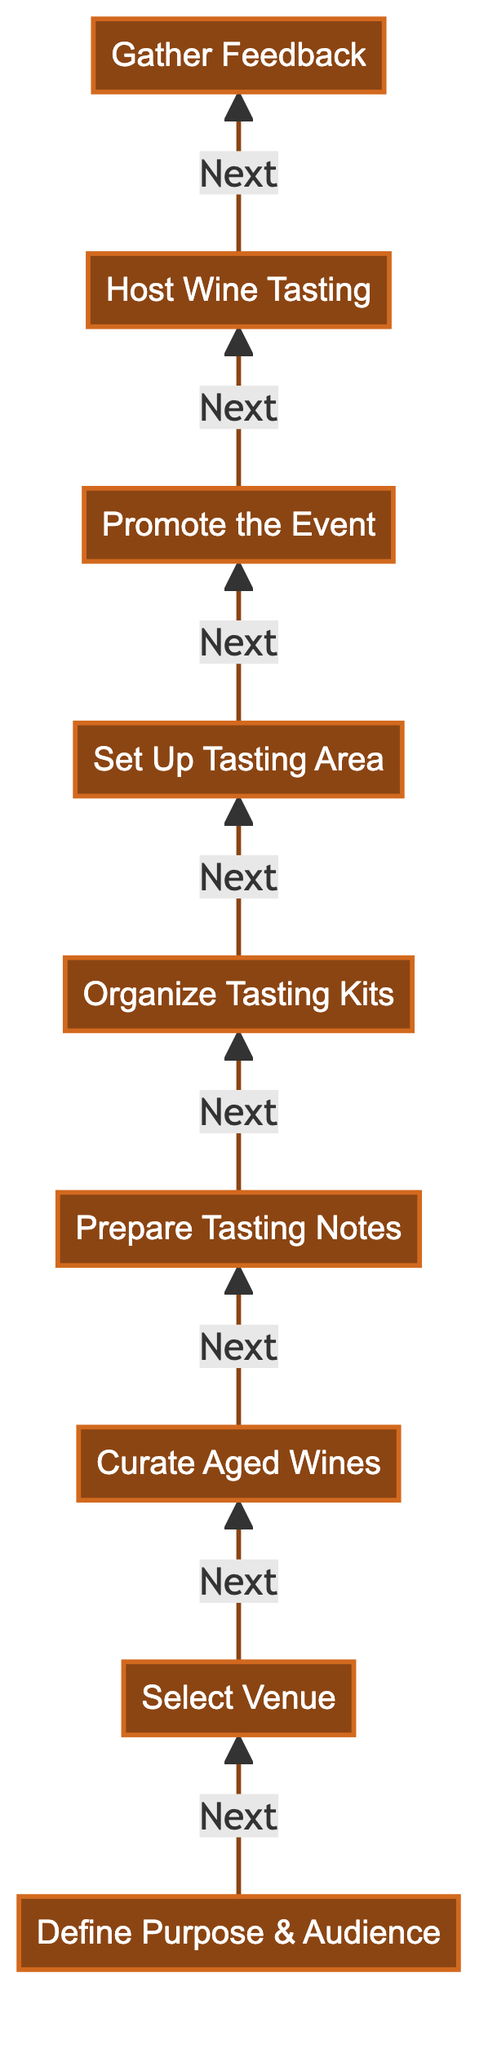What is the first step in organizing a wine tasting event? The diagram shows that the first step, pointed to by the arrow, is "Define Purpose & Audience." This is the starting point of the flowchart, and it directs the subsequent steps.
Answer: Define Purpose & Audience How many steps are there in total? By counting all nodes in the diagram, there are a total of nine steps listed from bottom to top. This includes all actions necessary for organizing the event.
Answer: Nine What is the last step in the process? The diagram indicates that the final step, the last node at the top, is "Gather Feedback." This implies it is the concluding action after hosting the tasting.
Answer: Gather Feedback Which step comes immediately before "Host Wine Tasting"? The diagram shows that "Promote the Event" is directly connected to "Host Wine Tasting" by an arrow pointing towards it; this means promoting is necessary before hosting.
Answer: Promote the Event What two steps directly follow "Curate Aged Wines"? Following "Curate Aged Wines," the next two steps according to the flowchart are "Prepare Tasting Notes" and "Organize Tasting Kits." This establishes a clear sequential process after curating wines.
Answer: Prepare Tasting Notes, Organize Tasting Kits What is the significance of the arrangement of the steps in this diagram? The bottom-to-top flowchart indicates a chronological order of tasks. Each step builds on the previous one, signifying progression towards the ultimate goal of successfully hosting the event.
Answer: Chronological order How many steps involve direct preparation for the event? Counting the steps, "Prepare Tasting Notes," "Organize Tasting Kits," and "Set Up Tasting Area" are all focused on preparation, totaling three steps that directly prepare for the event.
Answer: Three What is the relationship between "Set Up Tasting Area" and "Host Wine Tasting"? "Set Up Tasting Area" comes right before "Host Wine Tasting" in the diagram, indicating that preparation of the tasting area is immediately necessary for successfully hosting the event.
Answer: Preparation before hosting Which step emphasizes the importance of participant interactions? The step "Host Wine Tasting" emphasizes interactions as it involves facilitating discussions and providing insights about the wines, indicating an engagement focus during this part of the event.
Answer: Host Wine Tasting 